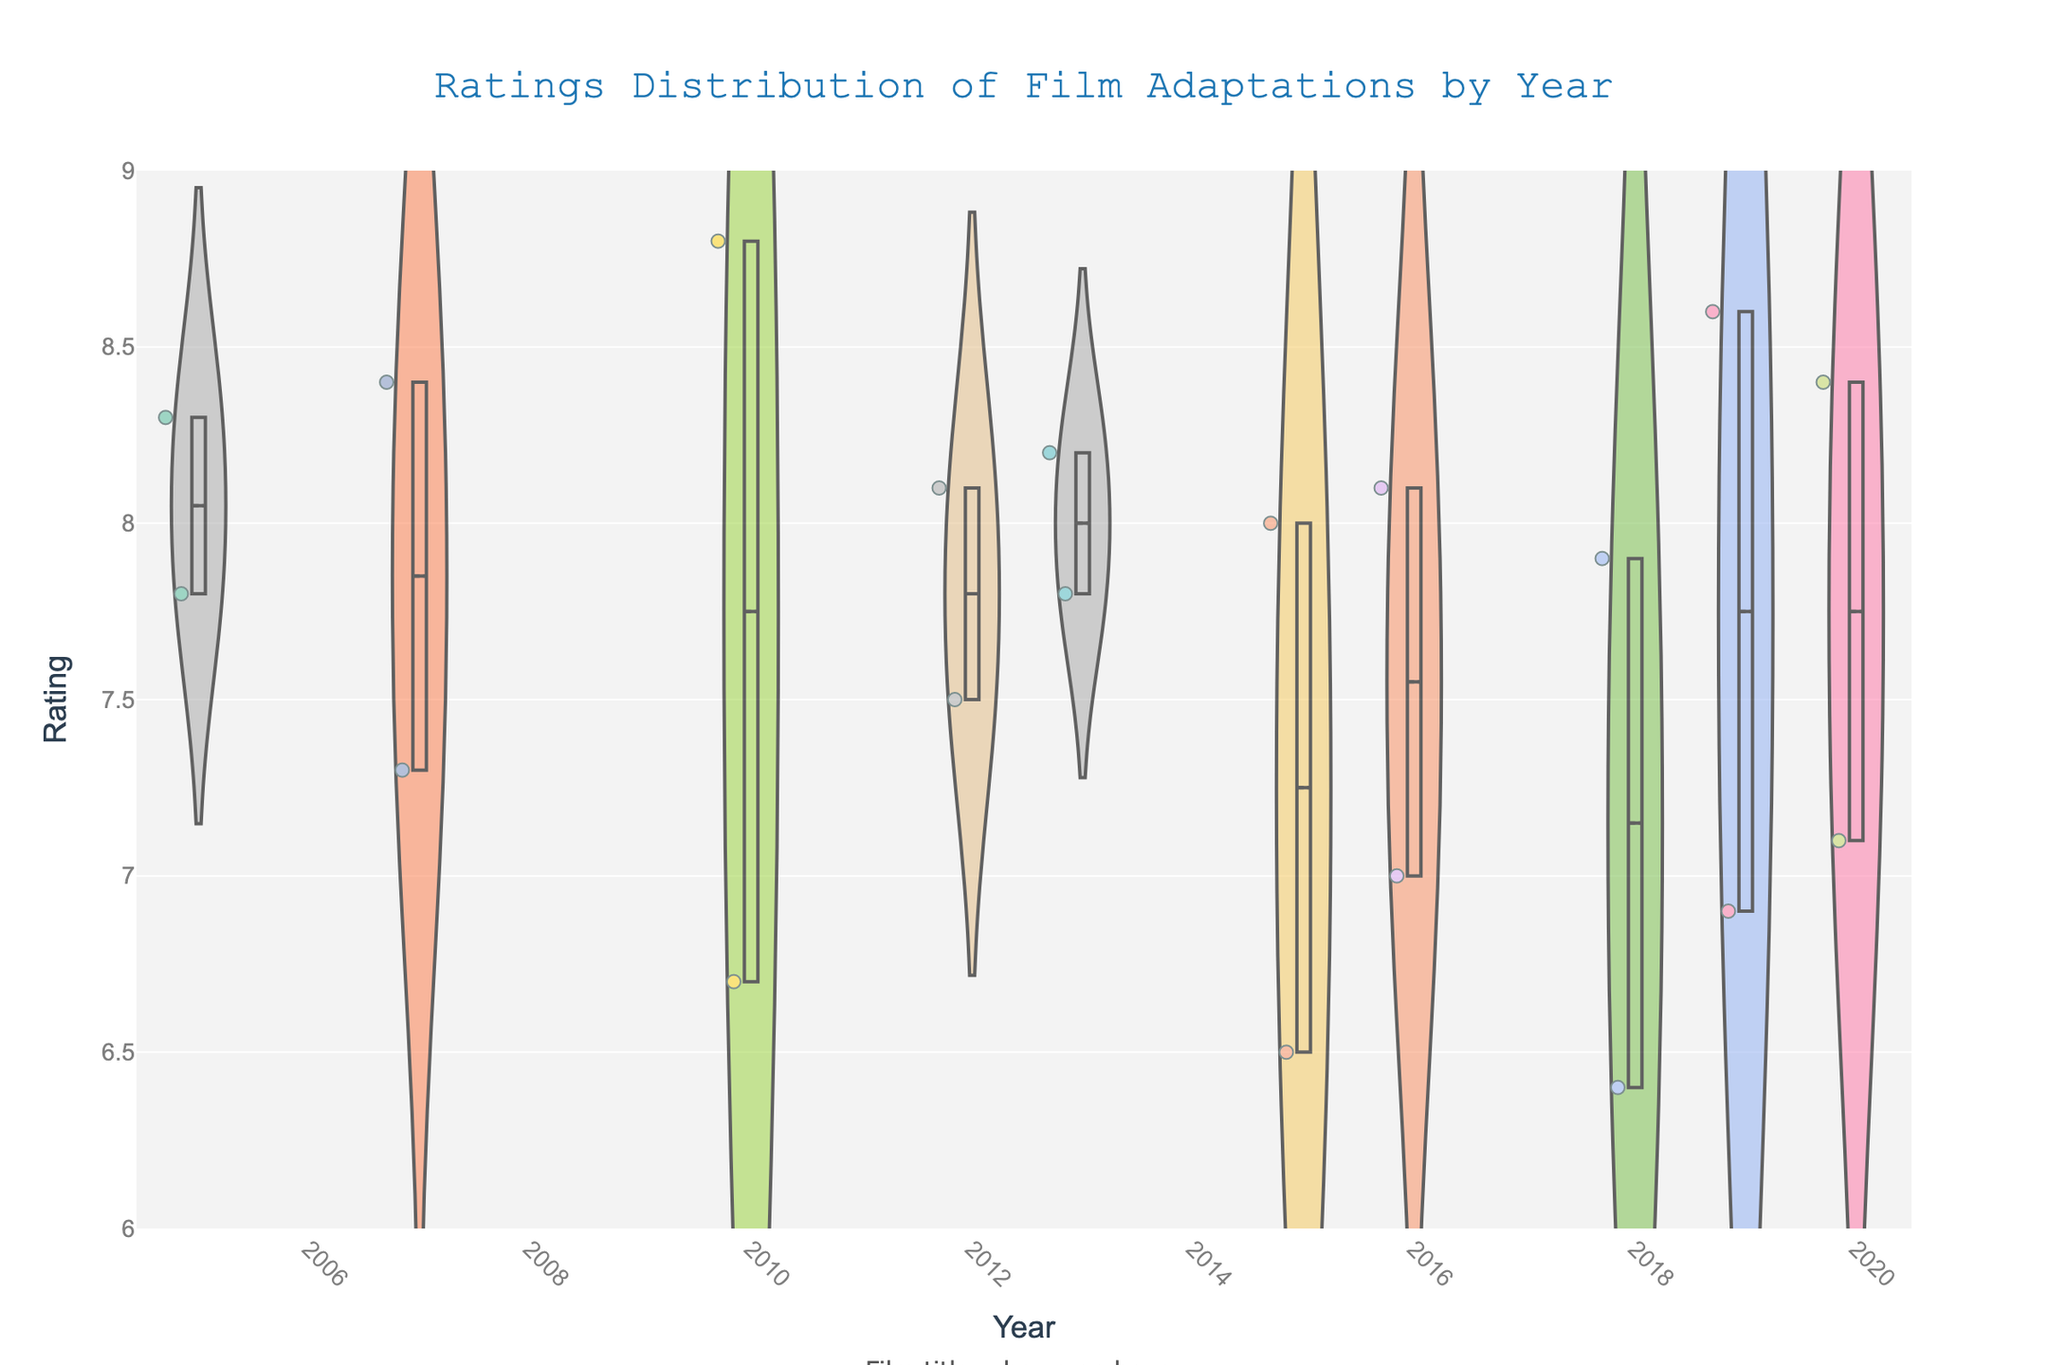What is the title of the figure? The title is displayed in a prominent position, typically at the top of the graph. It reads "Ratings Distribution of Film Adaptations by Year".
Answer: Ratings Distribution of Film Adaptations by Year What are the labels of the x-axis and y-axis? The labels for the axes are typically placed along the respective axis. The x-axis is labeled "Year," and the y-axis is labeled "Rating."
Answer: Year; Rating What is the range of the y-axis? The y-axis values can be observed from the plot. It ranges from 6 to 9.
Answer: 6 to 9 Which year has the highest-rated film? By examining the jittered points within each year's violin plot, the highest rating can be found. The year 2010 shows a rating of 8.8 for "The Social Network," which is the highest rating in the figure.
Answer: 2010 Is there any year where both the lowest and highest ratings are close to each other? By examining the box plots within the violins, 2007 and 2010 have films with relatively close ratings. In particular, 2010 has films rated 6.7 and 8.8.
Answer: 2010 Which year shows the most variability in film ratings? Variability can be assessed by looking at the spread of the violin plots. The year 2018 shows the widest spread from 6.4 ("A Wrinkle in Time") to 7.9 ("Ready Player One"), indicating high variability.
Answer: 2018 How many films were adapted in 2012, and what are their ratings? By counting the data points within the 2012 violin part of the figure, we see there are two films with ratings 7.5 and 8.1.
Answer: Two films, ratings are 7.5 and 8.1 Which specific film has the highest rating, and how do you know? By examining the hover text on the jittered points, "The Social Network" in 2010 has the highest rating of 8.8.
Answer: The Social Network What is the average rating for the year 2015? The ratings for 2015 are 6.5 and 8.0, and the average is calculated by (6.5 + 8.0)/2.
Answer: 7.25 Which years have films rated above 8.0? By checking the ratings, the years 2005, 2007, 2010, 2012, 2013, 2015, 2016, 2018, and 2019 have films with ratings above 8.0.
Answer: 2005, 2007, 2010, 2012, 2013, 2015, 2016, 2018, 2019 